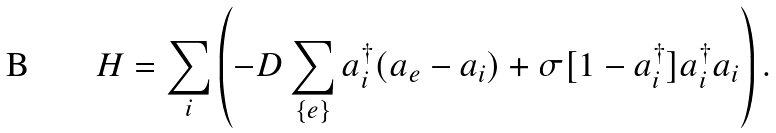Convert formula to latex. <formula><loc_0><loc_0><loc_500><loc_500>H = \sum _ { i } \left ( - D \sum _ { \{ e \} } a ^ { \dag } _ { i } ( a _ { e } - a _ { i } ) + \sigma [ 1 - a ^ { \dag } _ { i } ] a ^ { \dag } _ { i } a _ { i } \right ) .</formula> 